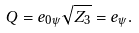<formula> <loc_0><loc_0><loc_500><loc_500>Q = e _ { 0 \psi } \sqrt { Z _ { 3 } } = e _ { \psi } .</formula> 